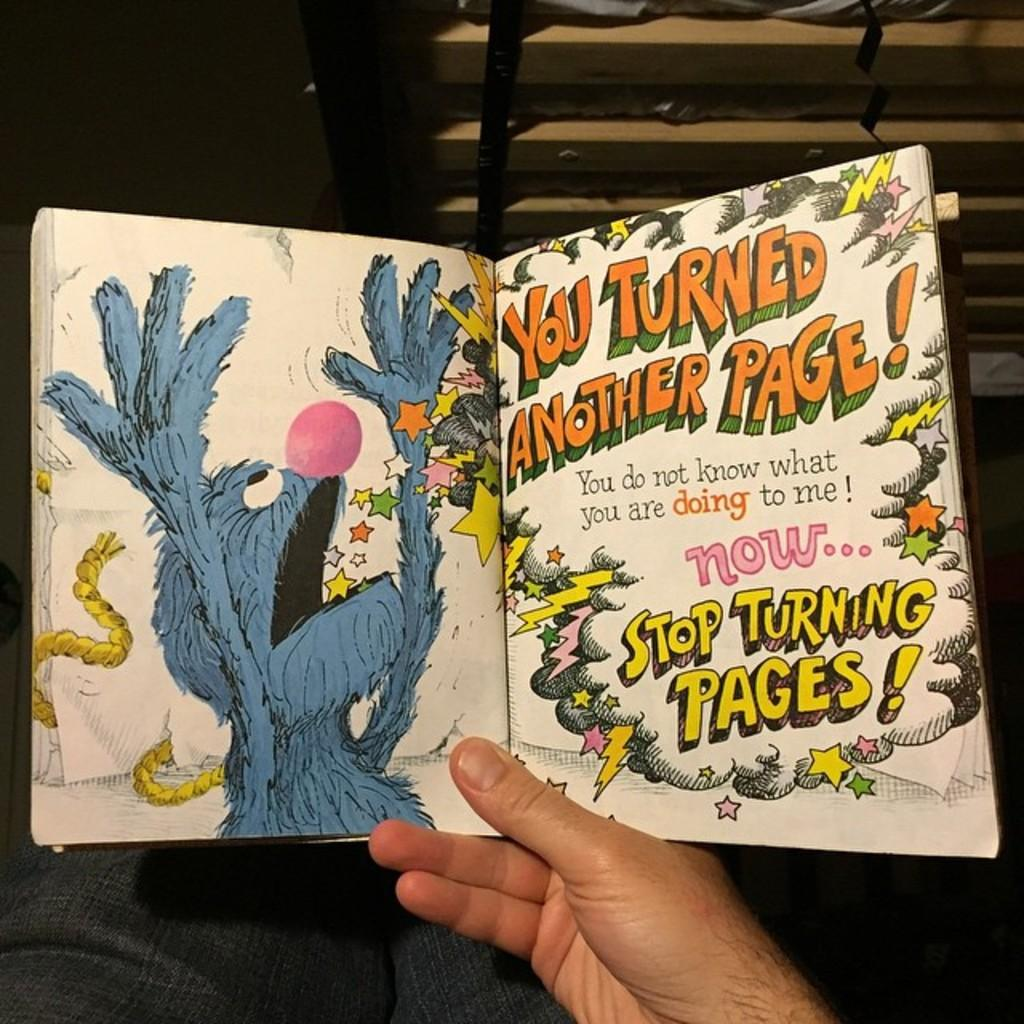What is the main subject of the image? There is a person in the image. What is the person holding in their hand? The person is holding a book in their hand. Which parts of the person are visible in the image? Only the hand and legs of the person are visible in the image. What type of stitch is being used to sew the book in the image? There is no stitching or sewing visible in the image; the person is simply holding a book. How does the wind affect the person's legs in the image? There is no mention of wind or any weather conditions in the image; the person's legs are stationary. 